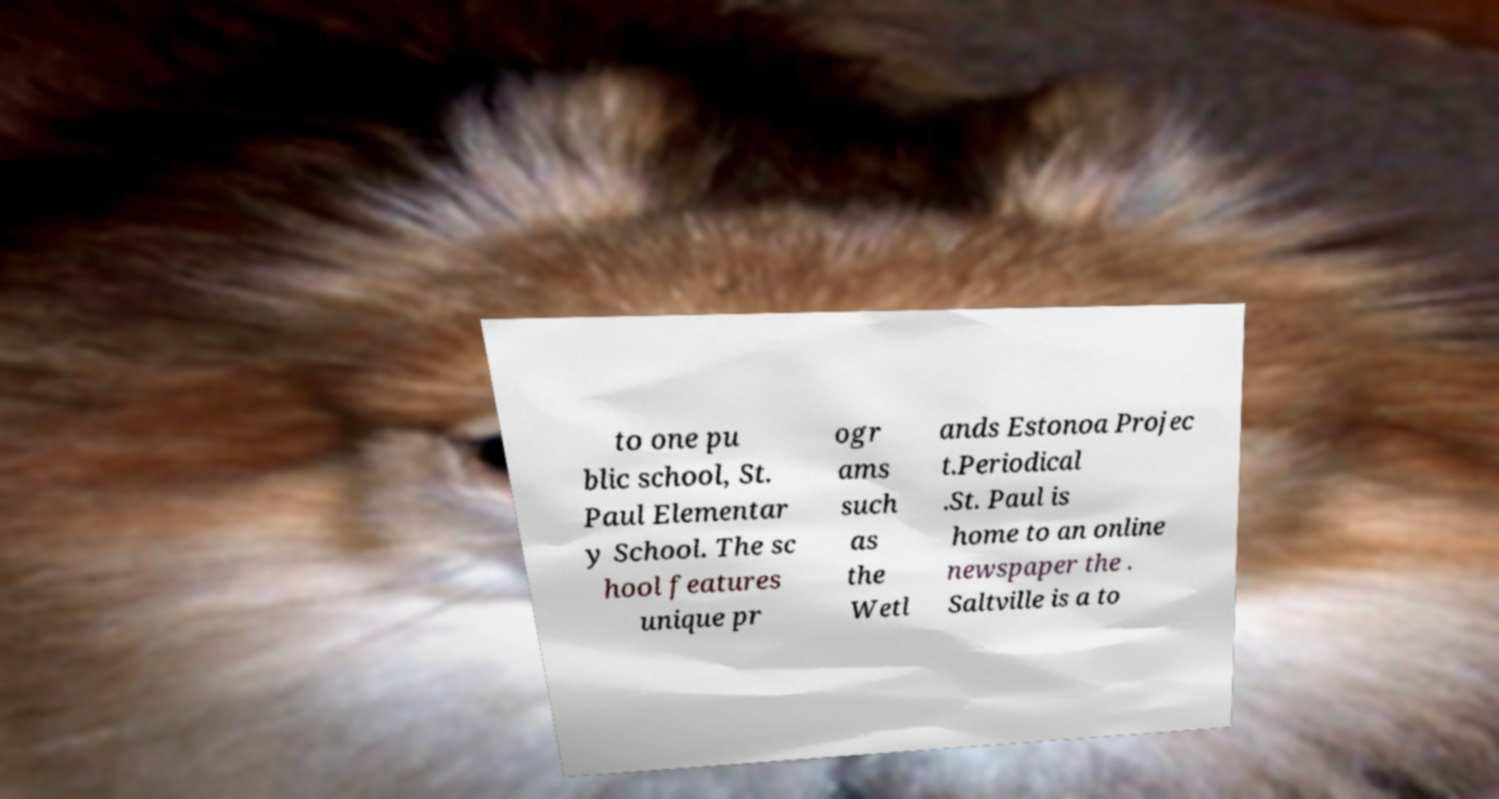I need the written content from this picture converted into text. Can you do that? to one pu blic school, St. Paul Elementar y School. The sc hool features unique pr ogr ams such as the Wetl ands Estonoa Projec t.Periodical .St. Paul is home to an online newspaper the . Saltville is a to 